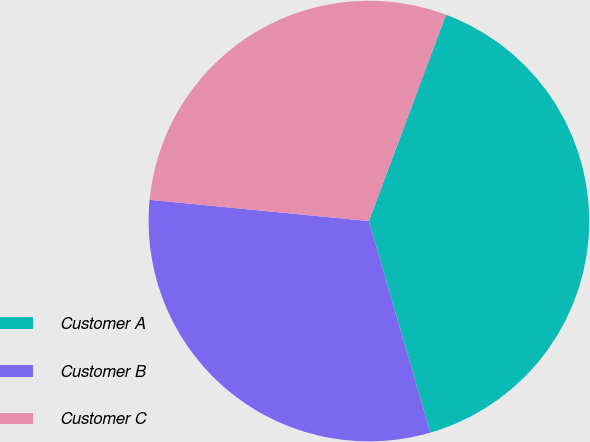Convert chart. <chart><loc_0><loc_0><loc_500><loc_500><pie_chart><fcel>Customer A<fcel>Customer B<fcel>Customer C<nl><fcel>39.81%<fcel>31.04%<fcel>29.15%<nl></chart> 